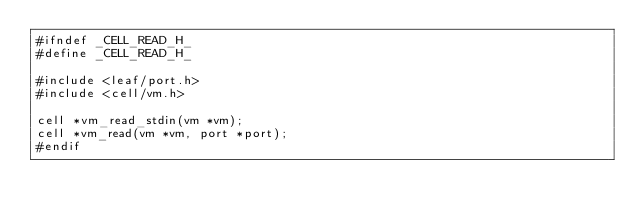Convert code to text. <code><loc_0><loc_0><loc_500><loc_500><_C_>#ifndef _CELL_READ_H_
#define _CELL_READ_H_

#include <leaf/port.h>
#include <cell/vm.h>

cell *vm_read_stdin(vm *vm);
cell *vm_read(vm *vm, port *port);
#endif

</code> 